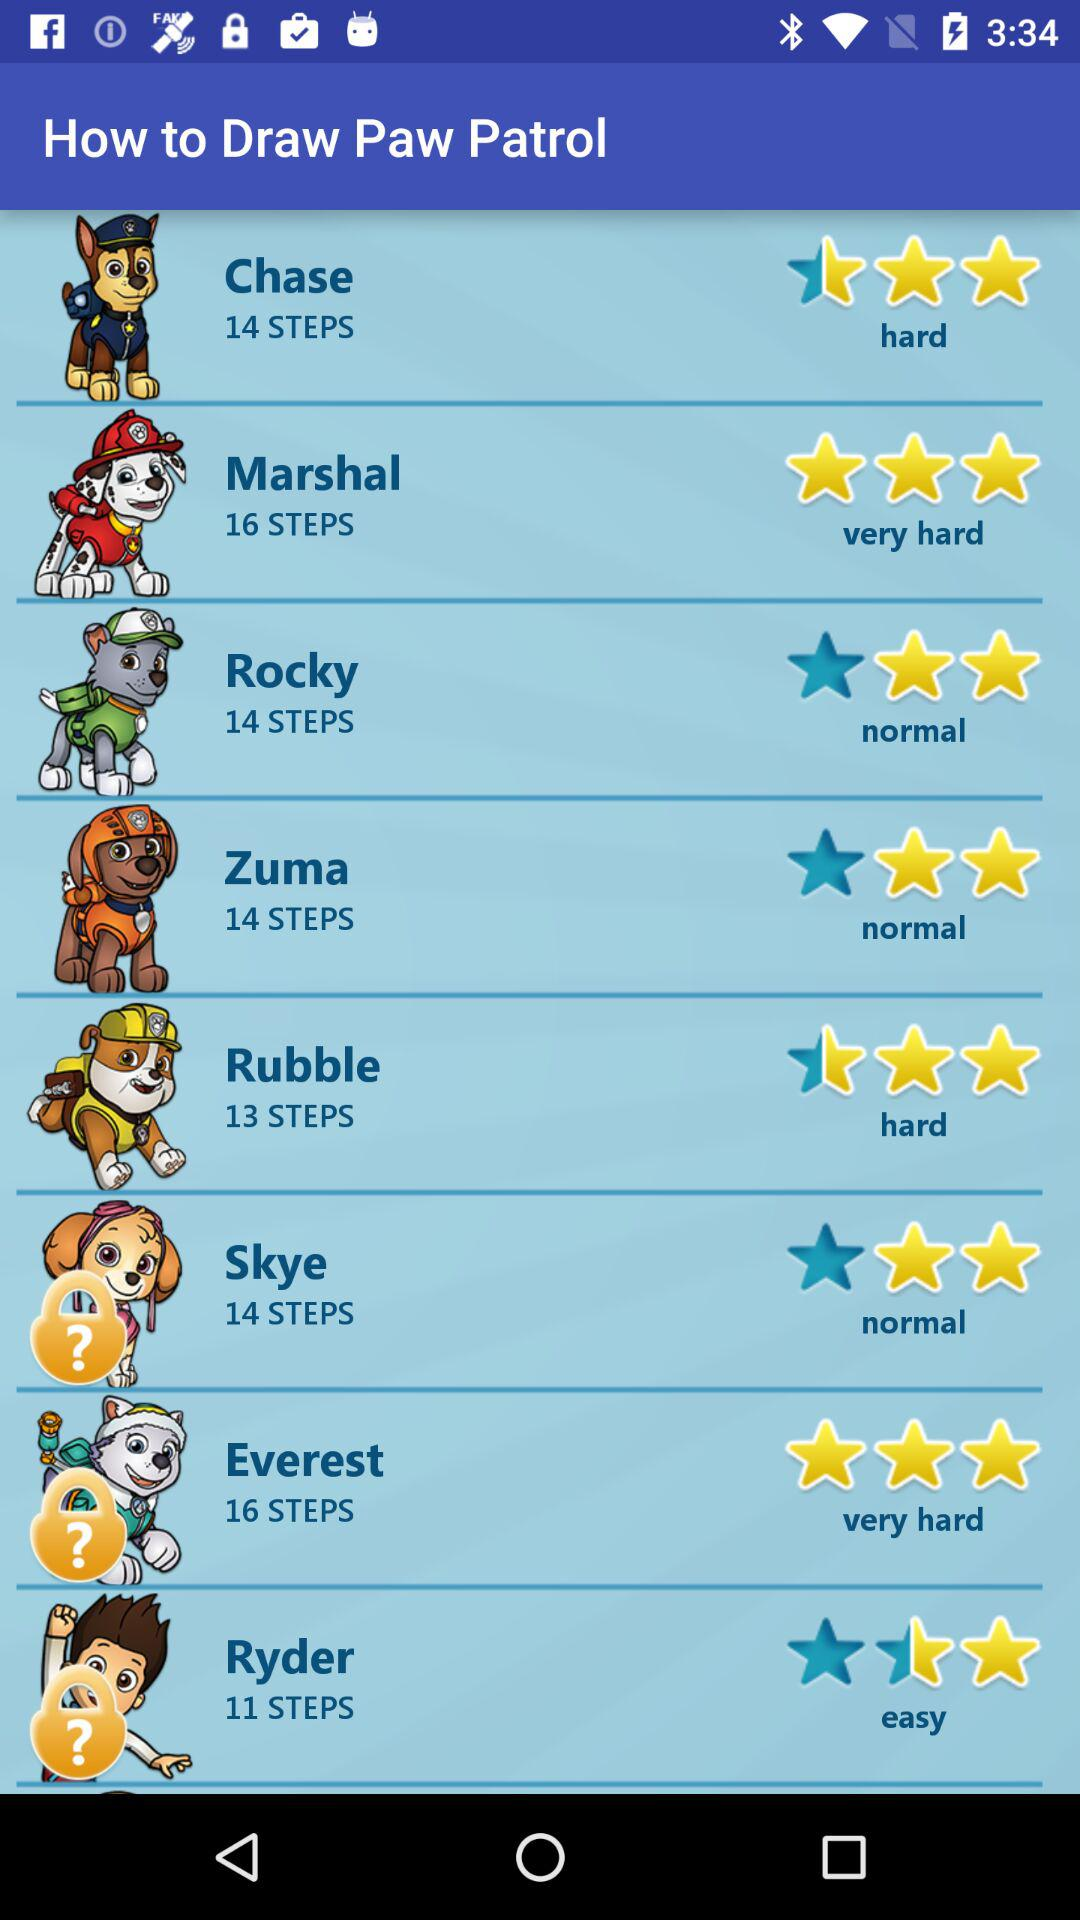How many steps are in "Zuma"? There are 14 steps. 